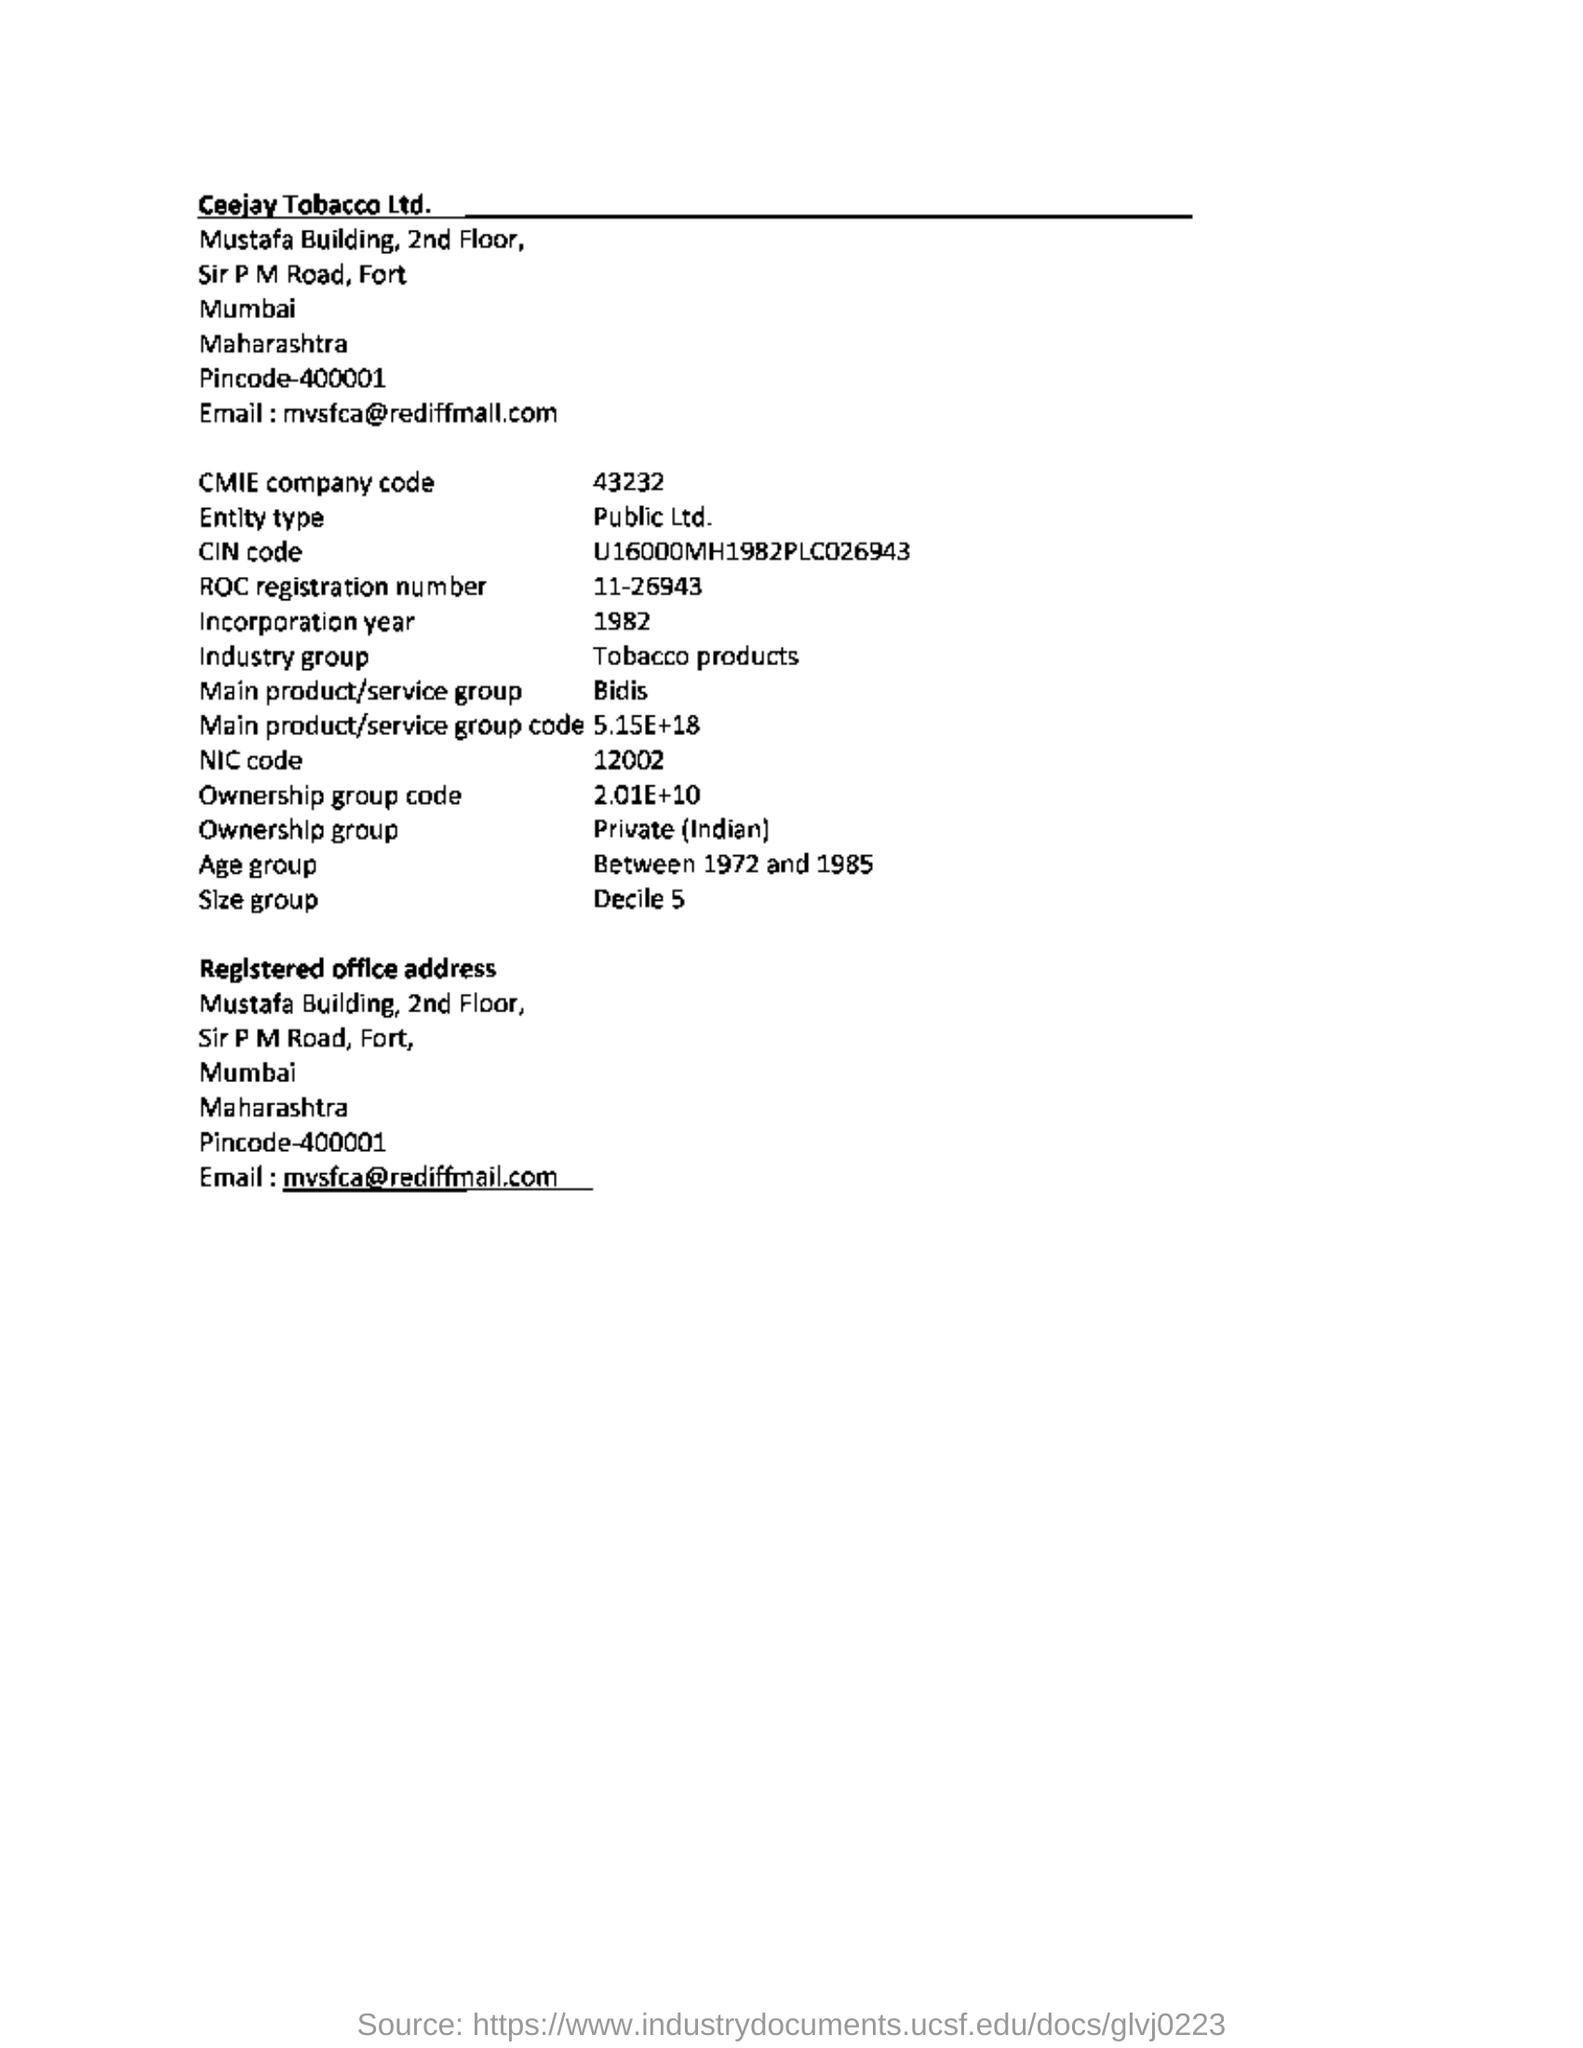What is the age group mentioned in the document?
Your answer should be very brief. Between 1972 and 1985. What is the main product of the company?
Keep it short and to the point. Bidis. What is the company code mentioned in the document?
Offer a very short reply. 43232. 